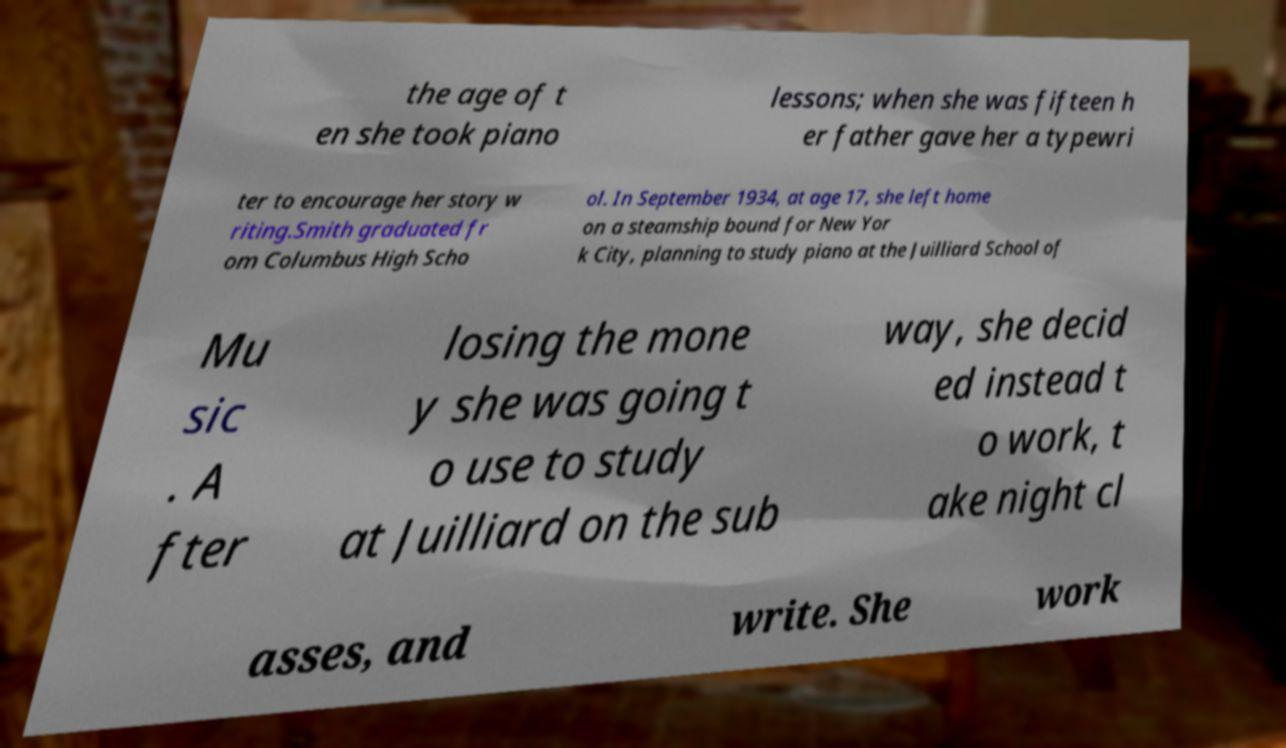Please read and relay the text visible in this image. What does it say? the age of t en she took piano lessons; when she was fifteen h er father gave her a typewri ter to encourage her story w riting.Smith graduated fr om Columbus High Scho ol. In September 1934, at age 17, she left home on a steamship bound for New Yor k City, planning to study piano at the Juilliard School of Mu sic . A fter losing the mone y she was going t o use to study at Juilliard on the sub way, she decid ed instead t o work, t ake night cl asses, and write. She work 